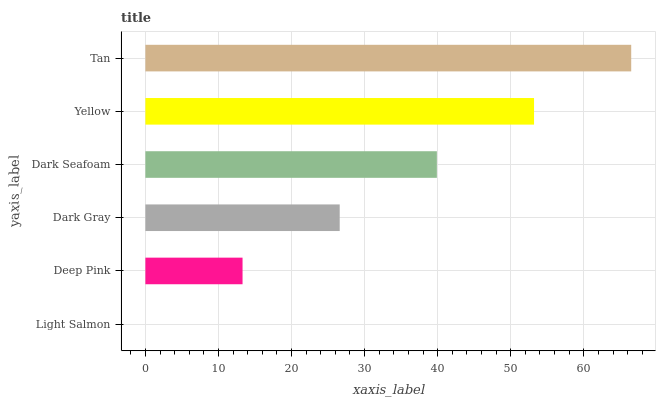Is Light Salmon the minimum?
Answer yes or no. Yes. Is Tan the maximum?
Answer yes or no. Yes. Is Deep Pink the minimum?
Answer yes or no. No. Is Deep Pink the maximum?
Answer yes or no. No. Is Deep Pink greater than Light Salmon?
Answer yes or no. Yes. Is Light Salmon less than Deep Pink?
Answer yes or no. Yes. Is Light Salmon greater than Deep Pink?
Answer yes or no. No. Is Deep Pink less than Light Salmon?
Answer yes or no. No. Is Dark Seafoam the high median?
Answer yes or no. Yes. Is Dark Gray the low median?
Answer yes or no. Yes. Is Light Salmon the high median?
Answer yes or no. No. Is Yellow the low median?
Answer yes or no. No. 